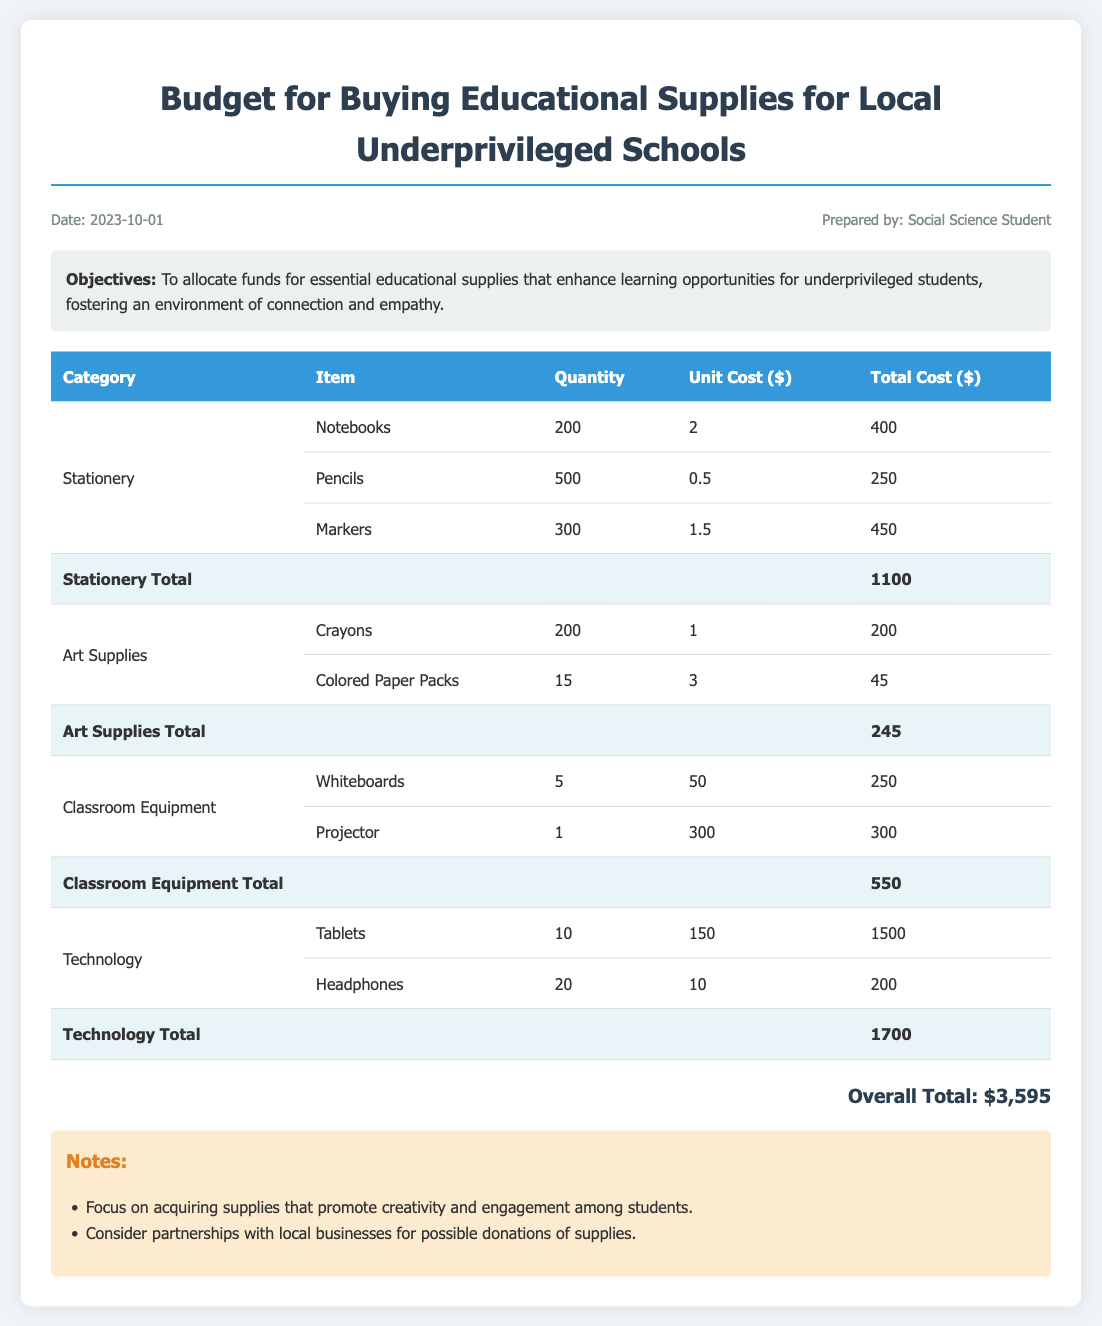What is the date of the budget preparation? The date of the budget preparation is stated in the meta-info section of the document.
Answer: 2023-10-01 Who prepared the budget? The budget is prepared by the individual mentioned in the meta-info section.
Answer: Social Science Student What is the total cost for technology? The total cost for technology can be found in the last category of the table.
Answer: 1700 How many notebooks are planned for purchase? The planned quantity of notebooks is indicated in the stationery section of the table.
Answer: 200 What is the overall total amount of the budget? The overall total is provided at the end of the document as a summary of all expenses.
Answer: 3595 What is the objective of the budget? The objective is highlighted in the objectives section, outlining the purpose of funding allocation.
Answer: To allocate funds for essential educational supplies How many different categories of supplies are listed in the budget? The number of categories can be determined by counting the unique ones in the table.
Answer: 4 What is the unit cost of one tablet? The unit cost of tablets is specified in the technology section of the table.
Answer: 150 Which item has the highest total cost? The item with the highest total cost can be identified in the technology section.
Answer: Tablets 